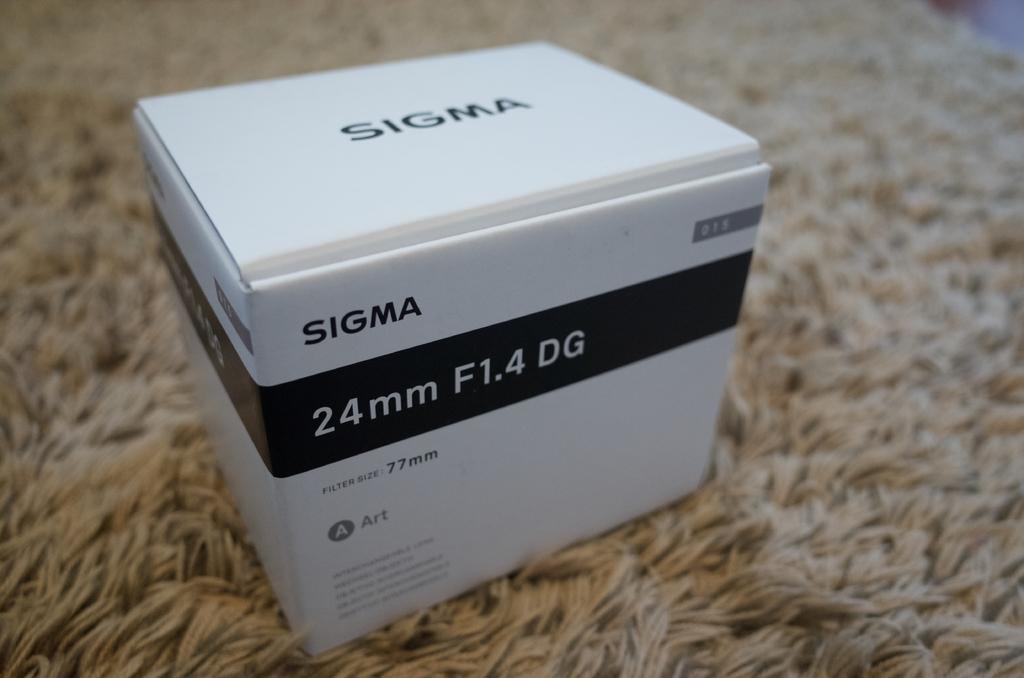What brand is in the box?
Provide a short and direct response. Sigma. How many mm is the lens?
Your response must be concise. 24. 